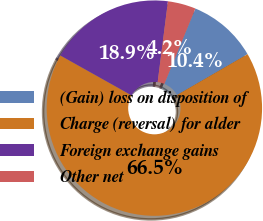Convert chart. <chart><loc_0><loc_0><loc_500><loc_500><pie_chart><fcel>(Gain) loss on disposition of<fcel>Charge (reversal) for alder<fcel>Foreign exchange gains<fcel>Other net<nl><fcel>10.43%<fcel>66.48%<fcel>18.89%<fcel>4.2%<nl></chart> 